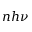Convert formula to latex. <formula><loc_0><loc_0><loc_500><loc_500>n h \nu</formula> 